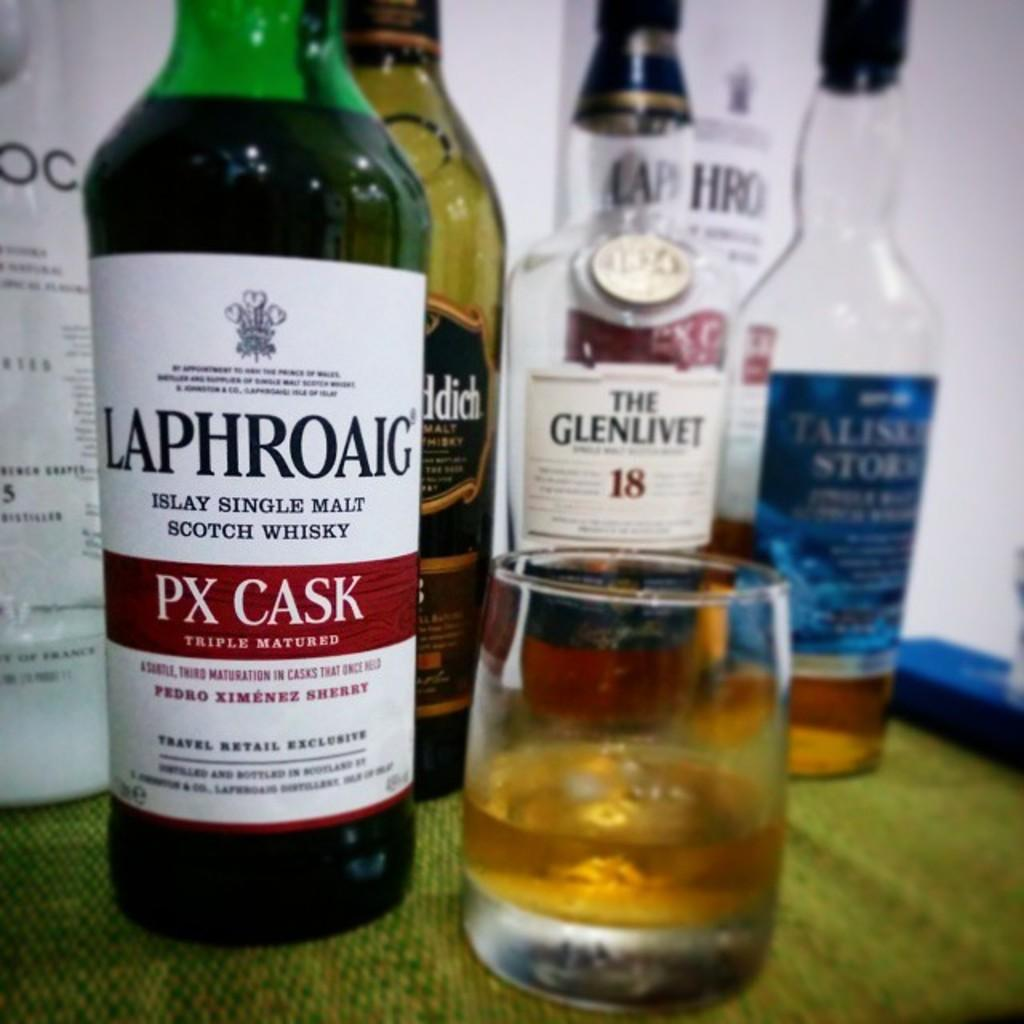<image>
Share a concise interpretation of the image provided. A battle by Laphroaig is next to a bottle of Glenlivet. 